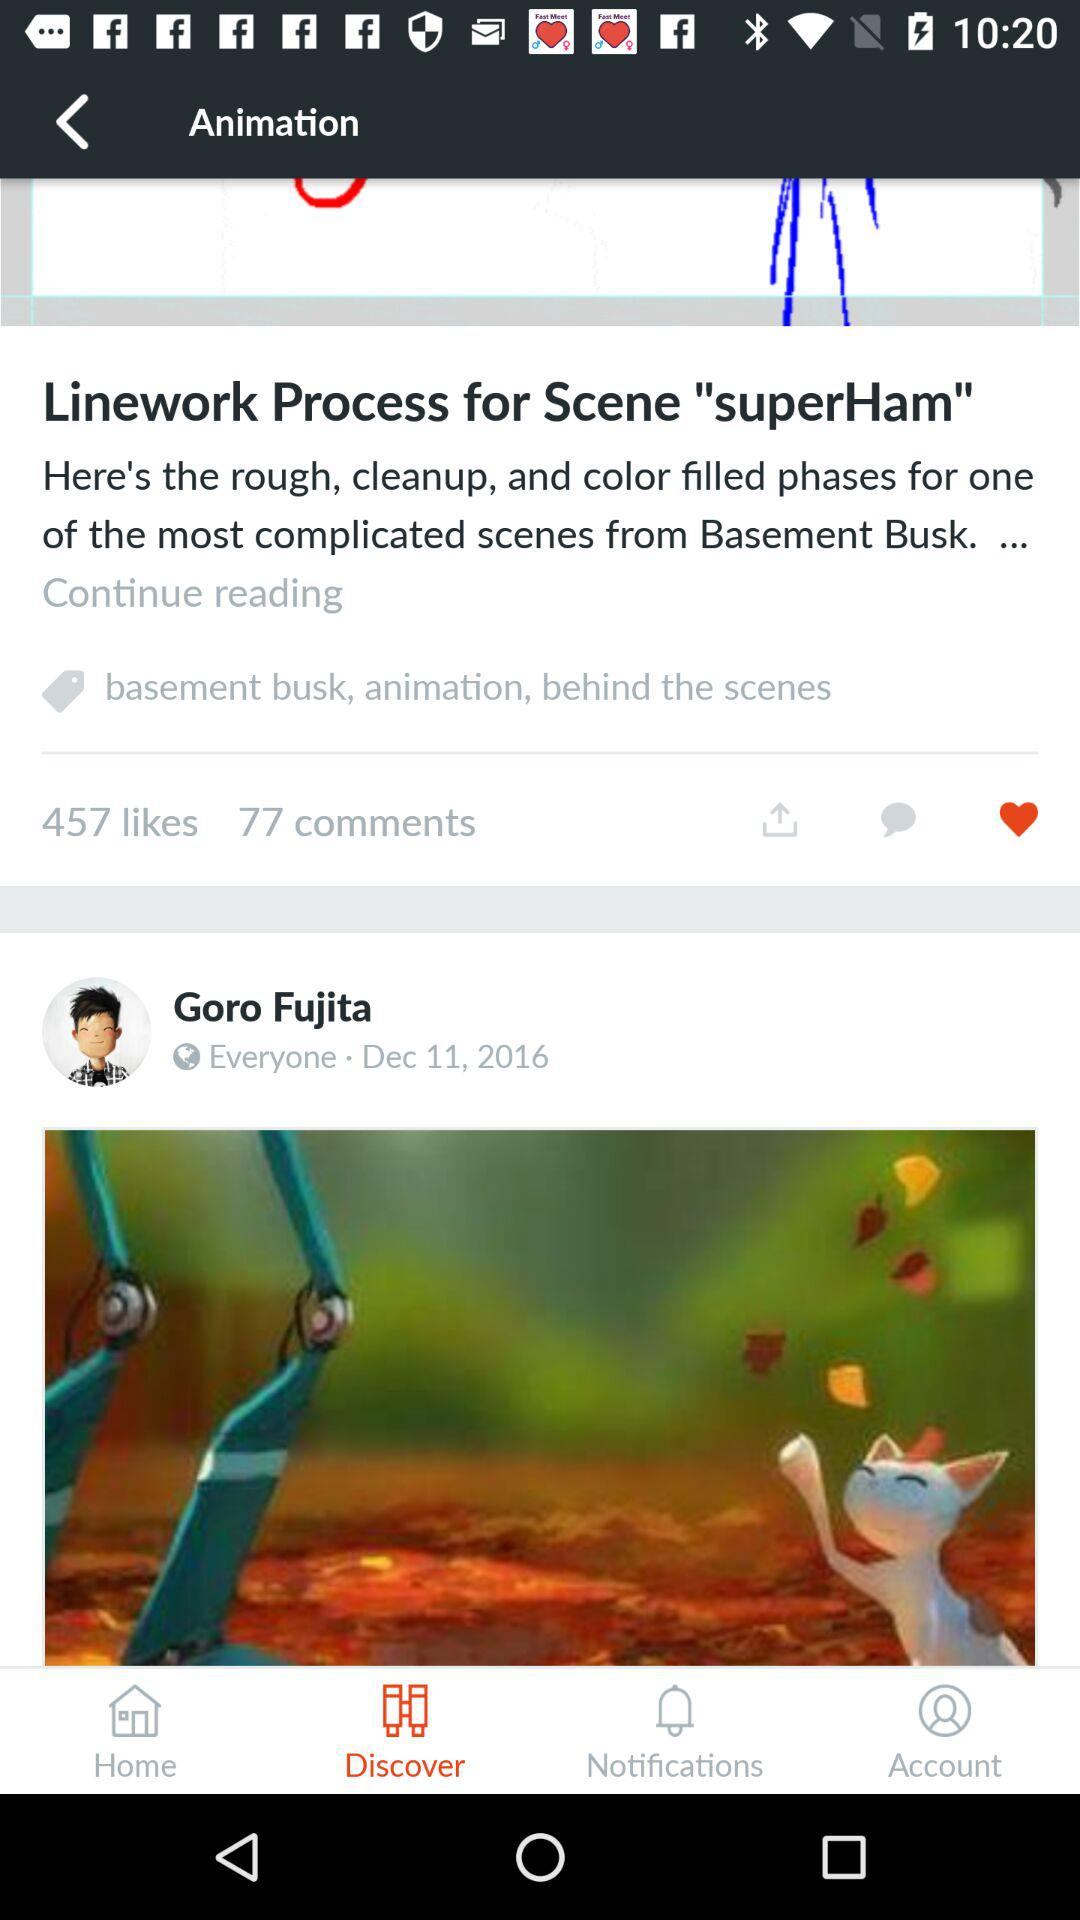What is the name of the person who posted this?
Answer the question using a single word or phrase. Goro Fujita 